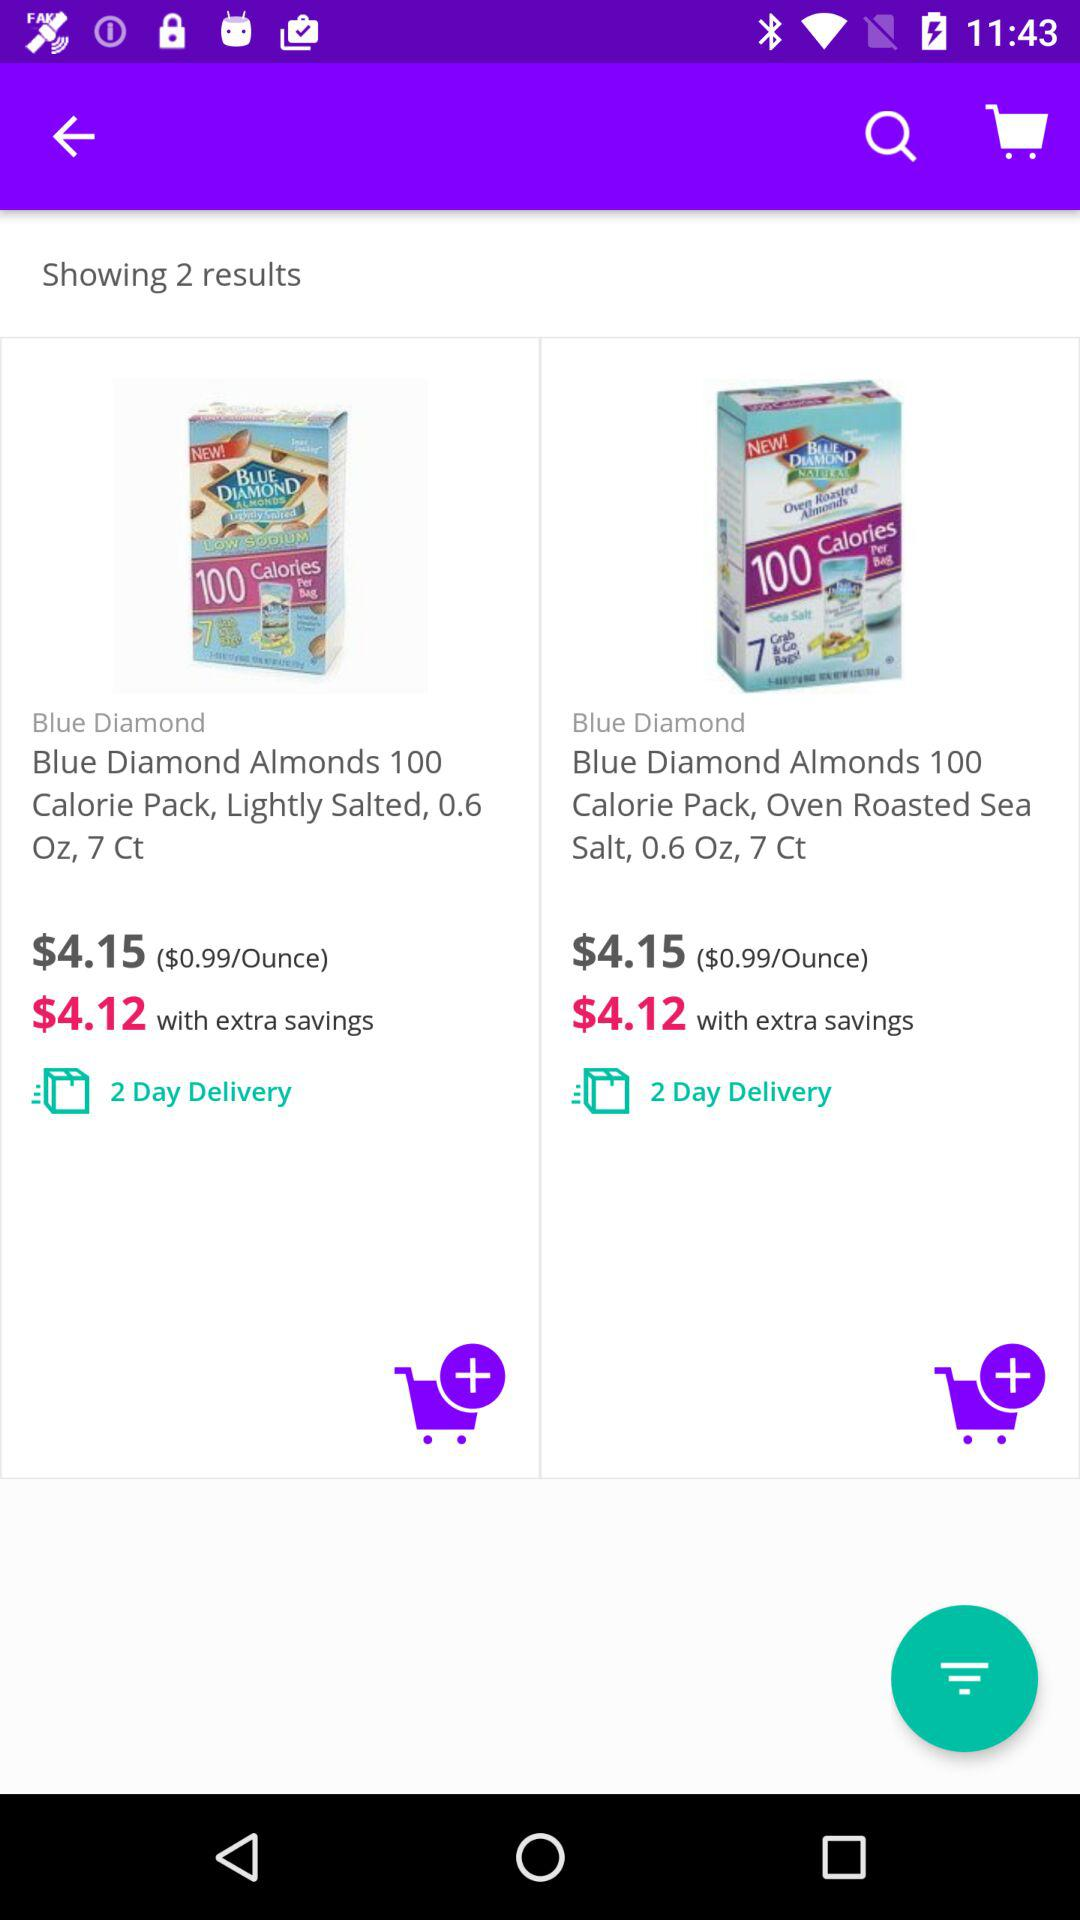Can you tell me more about the product shown in these search results? The search results display two products from the Blue Diamond brand, offering Almonds in 100 Calorie Packs. Both are 0.6 ounces and come in 7-count boxes. One is lightly salted while the other is oven roasted with sea salt. They are advertised at $4.15 each, with a possible extra savings bringing the price down to $4.12 each, and are available for 2-day delivery. 